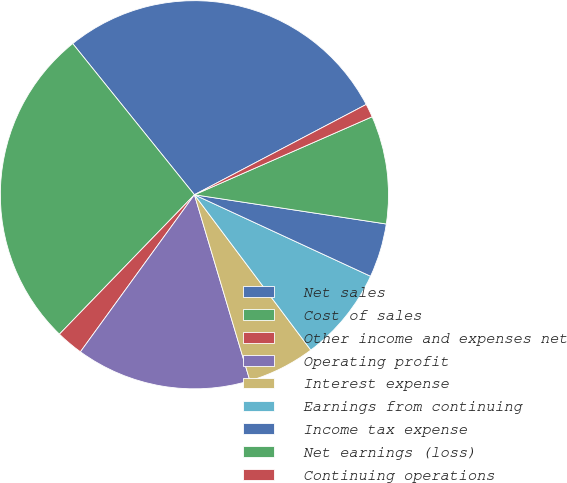Convert chart. <chart><loc_0><loc_0><loc_500><loc_500><pie_chart><fcel>Net sales<fcel>Cost of sales<fcel>Other income and expenses net<fcel>Operating profit<fcel>Interest expense<fcel>Earnings from continuing<fcel>Income tax expense<fcel>Net earnings (loss)<fcel>Continuing operations<nl><fcel>28.09%<fcel>26.97%<fcel>2.25%<fcel>14.61%<fcel>5.62%<fcel>7.87%<fcel>4.49%<fcel>8.99%<fcel>1.12%<nl></chart> 